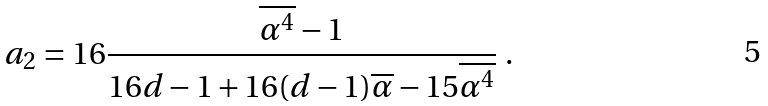<formula> <loc_0><loc_0><loc_500><loc_500>a _ { 2 } = 1 6 \frac { \overline { \alpha ^ { 4 } } - 1 } { 1 6 d - 1 + 1 6 ( d - 1 ) \overline { \alpha } - 1 5 \overline { \alpha ^ { 4 } } } \ .</formula> 